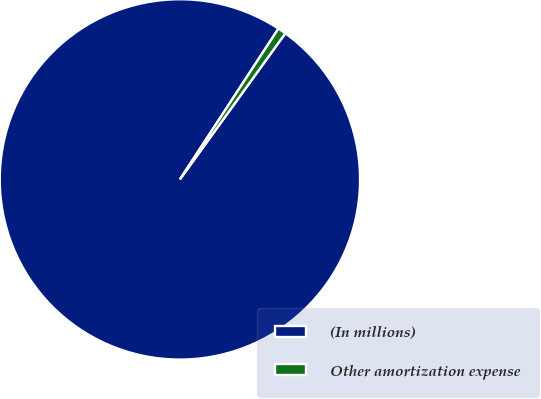<chart> <loc_0><loc_0><loc_500><loc_500><pie_chart><fcel>(In millions)<fcel>Other amortization expense<nl><fcel>99.26%<fcel>0.74%<nl></chart> 